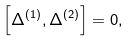<formula> <loc_0><loc_0><loc_500><loc_500>\left [ \Delta ^ { \left ( 1 \right ) } , \Delta ^ { \left ( 2 \right ) } \right ] = 0 ,</formula> 